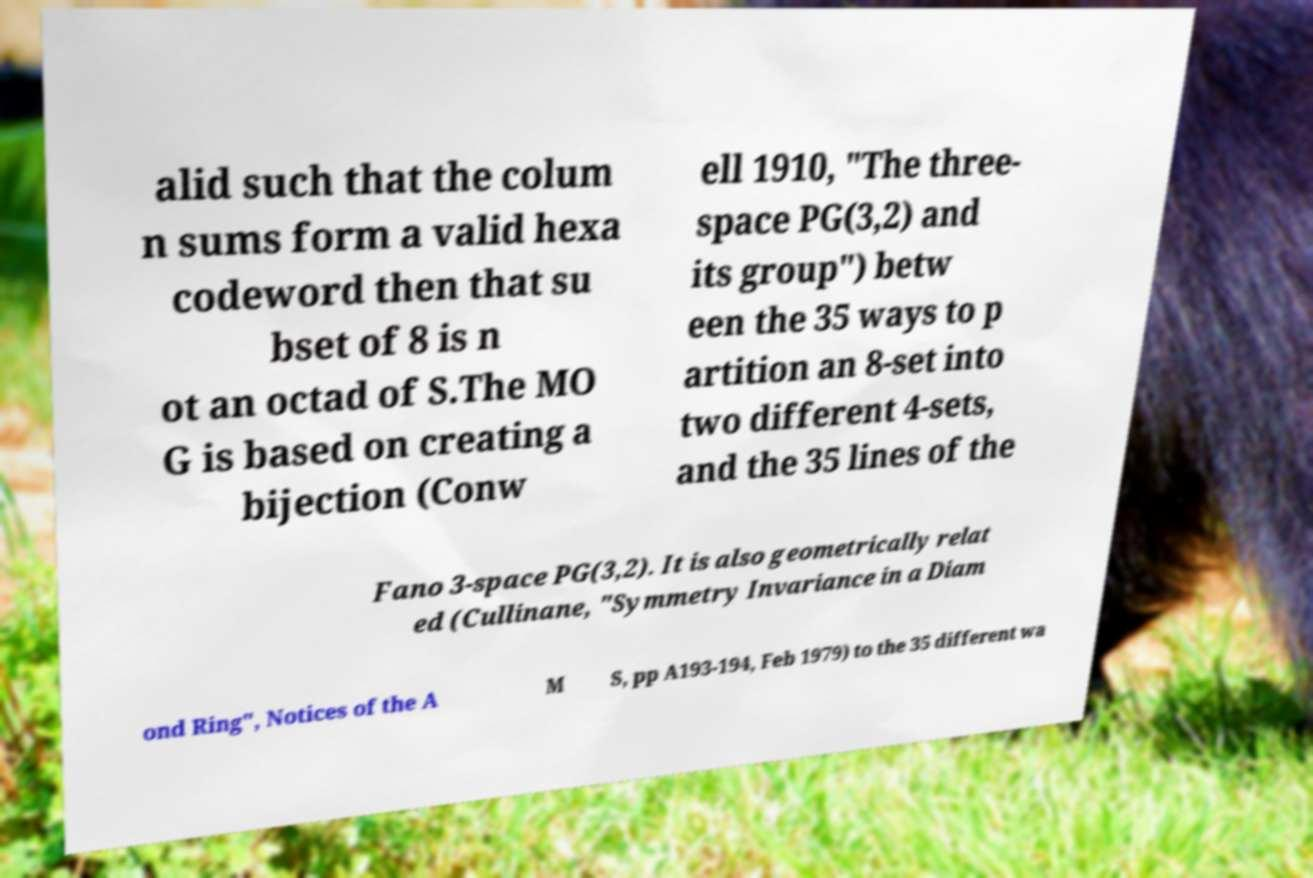Please identify and transcribe the text found in this image. alid such that the colum n sums form a valid hexa codeword then that su bset of 8 is n ot an octad of S.The MO G is based on creating a bijection (Conw ell 1910, "The three- space PG(3,2) and its group") betw een the 35 ways to p artition an 8-set into two different 4-sets, and the 35 lines of the Fano 3-space PG(3,2). It is also geometrically relat ed (Cullinane, "Symmetry Invariance in a Diam ond Ring", Notices of the A M S, pp A193-194, Feb 1979) to the 35 different wa 